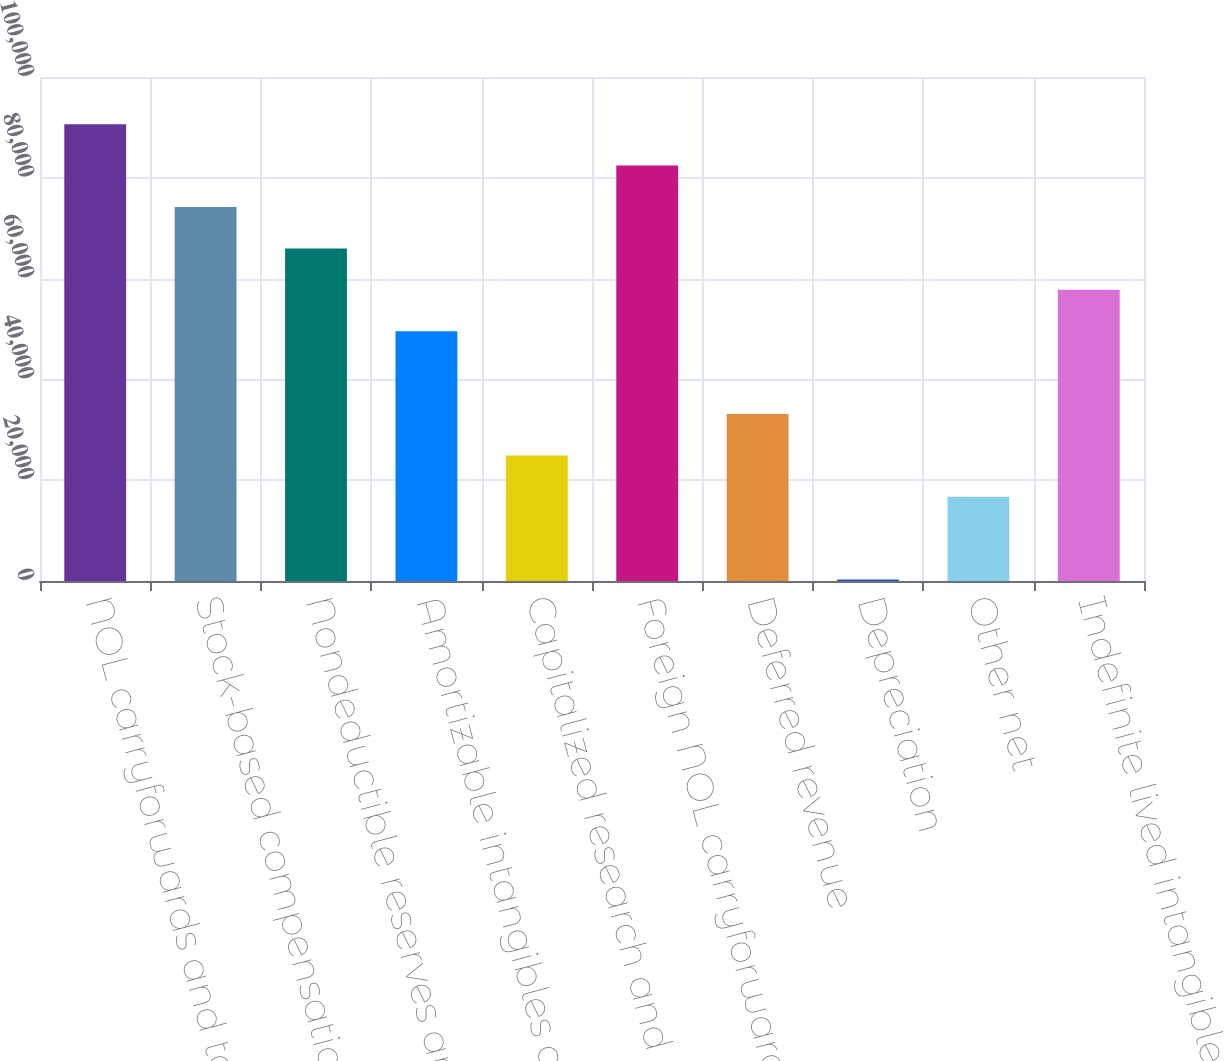Convert chart to OTSL. <chart><loc_0><loc_0><loc_500><loc_500><bar_chart><fcel>NOL carryforwards and tax<fcel>Stock-based compensation<fcel>Nondeductible reserves and<fcel>Amortizable intangibles other<fcel>Capitalized research and<fcel>Foreign NOL carryforwards<fcel>Deferred revenue<fcel>Depreciation<fcel>Other net<fcel>Indefinite lived intangibles<nl><fcel>90637.7<fcel>74208.3<fcel>65993.6<fcel>49564.2<fcel>24920.1<fcel>82423<fcel>33134.8<fcel>276<fcel>16705.4<fcel>57778.9<nl></chart> 